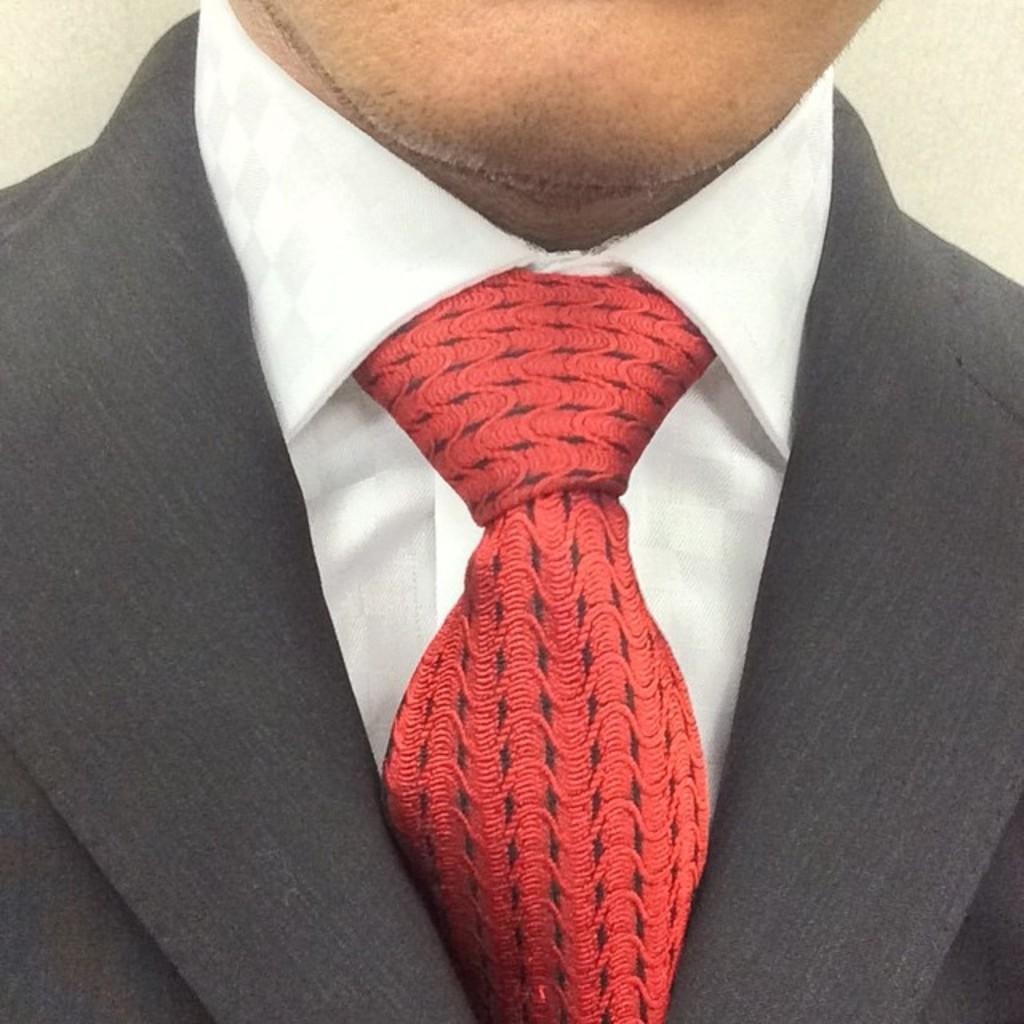What is present in the image? There is a person in the image. Can you describe the person's attire? The person is wearing a blazer. What type of berry is the person holding in the image? There is no berry present in the image. 